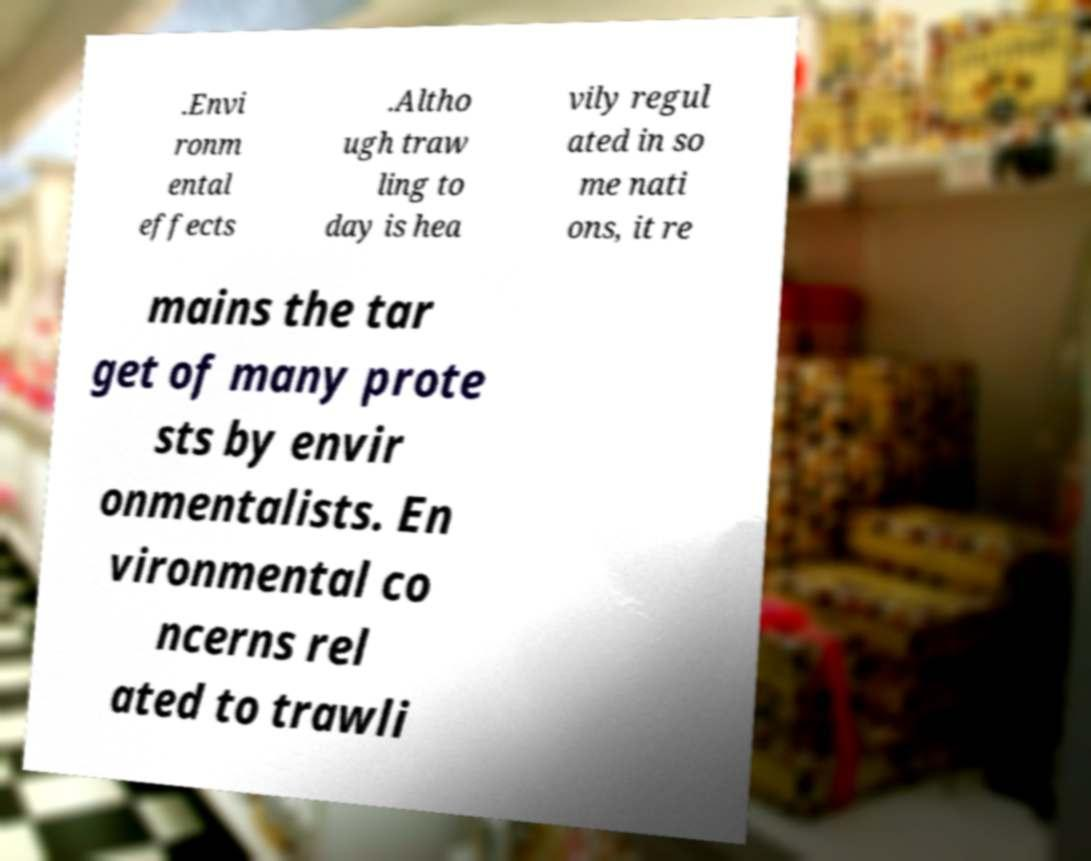For documentation purposes, I need the text within this image transcribed. Could you provide that? .Envi ronm ental effects .Altho ugh traw ling to day is hea vily regul ated in so me nati ons, it re mains the tar get of many prote sts by envir onmentalists. En vironmental co ncerns rel ated to trawli 